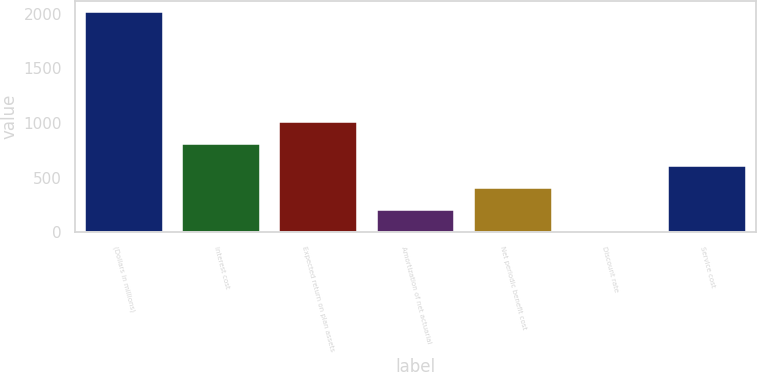Convert chart. <chart><loc_0><loc_0><loc_500><loc_500><bar_chart><fcel>(Dollars in millions)<fcel>Interest cost<fcel>Expected return on plan assets<fcel>Amortization of net actuarial<fcel>Net periodic benefit cost<fcel>Discount rate<fcel>Service cost<nl><fcel>2012<fcel>807.71<fcel>1008.42<fcel>205.58<fcel>406.29<fcel>4.87<fcel>607<nl></chart> 